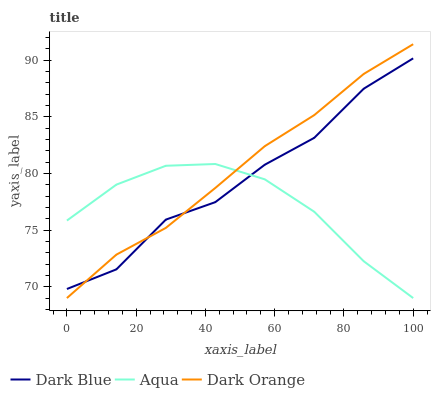Does Dark Orange have the minimum area under the curve?
Answer yes or no. No. Does Aqua have the maximum area under the curve?
Answer yes or no. No. Is Aqua the smoothest?
Answer yes or no. No. Is Aqua the roughest?
Answer yes or no. No. Does Aqua have the highest value?
Answer yes or no. No. 